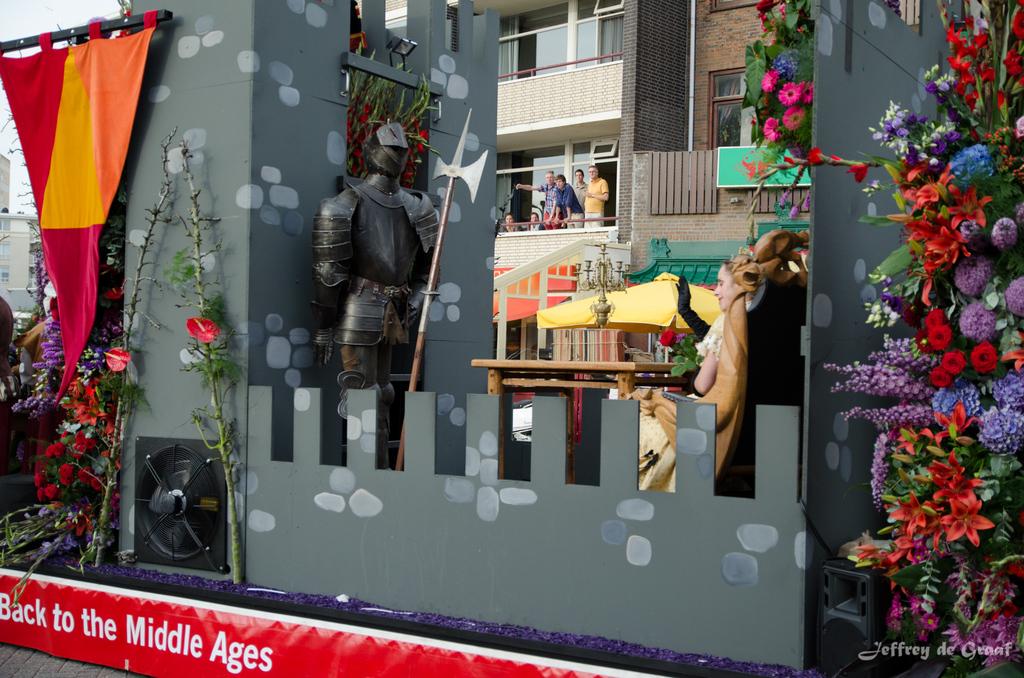Where is this float headed back to?
Make the answer very short. The middle ages. What time period is mentioned on the red banner?
Provide a succinct answer. Middle ages. 